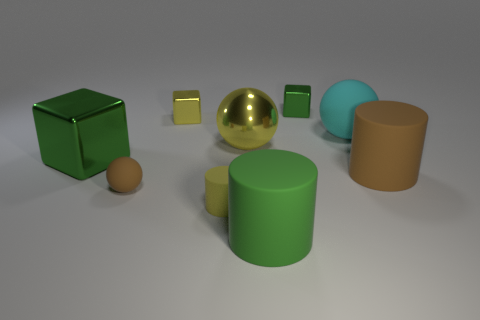Does the small cylinder have the same color as the big metal sphere?
Provide a short and direct response. Yes. There is a small shiny thing that is the same color as the shiny ball; what shape is it?
Provide a short and direct response. Cube. Does the big shiny object that is on the right side of the large green cube have the same color as the small cylinder?
Provide a short and direct response. Yes. There is a brown object that is left of the green object that is behind the big shiny ball; how big is it?
Offer a terse response. Small. Is the number of metallic things greater than the number of large purple matte cubes?
Your answer should be very brief. Yes. Is the number of green cylinders that are right of the large yellow object greater than the number of yellow matte cylinders behind the large green shiny object?
Your response must be concise. Yes. There is a block that is both to the left of the big yellow shiny ball and on the right side of the big cube; what size is it?
Your response must be concise. Small. What number of rubber cylinders are the same size as the cyan thing?
Your answer should be very brief. 2. There is a tiny cylinder that is the same color as the metallic ball; what is its material?
Provide a short and direct response. Rubber. There is a yellow metallic thing that is behind the cyan matte ball; does it have the same shape as the big green rubber thing?
Offer a terse response. No. 